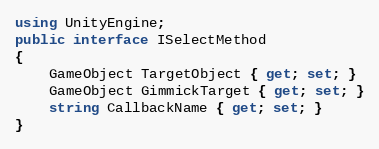Convert code to text. <code><loc_0><loc_0><loc_500><loc_500><_C#_>using UnityEngine;
public interface ISelectMethod
{
	GameObject TargetObject { get; set; }
	GameObject GimmickTarget { get; set; }
	string CallbackName { get; set; }
}</code> 